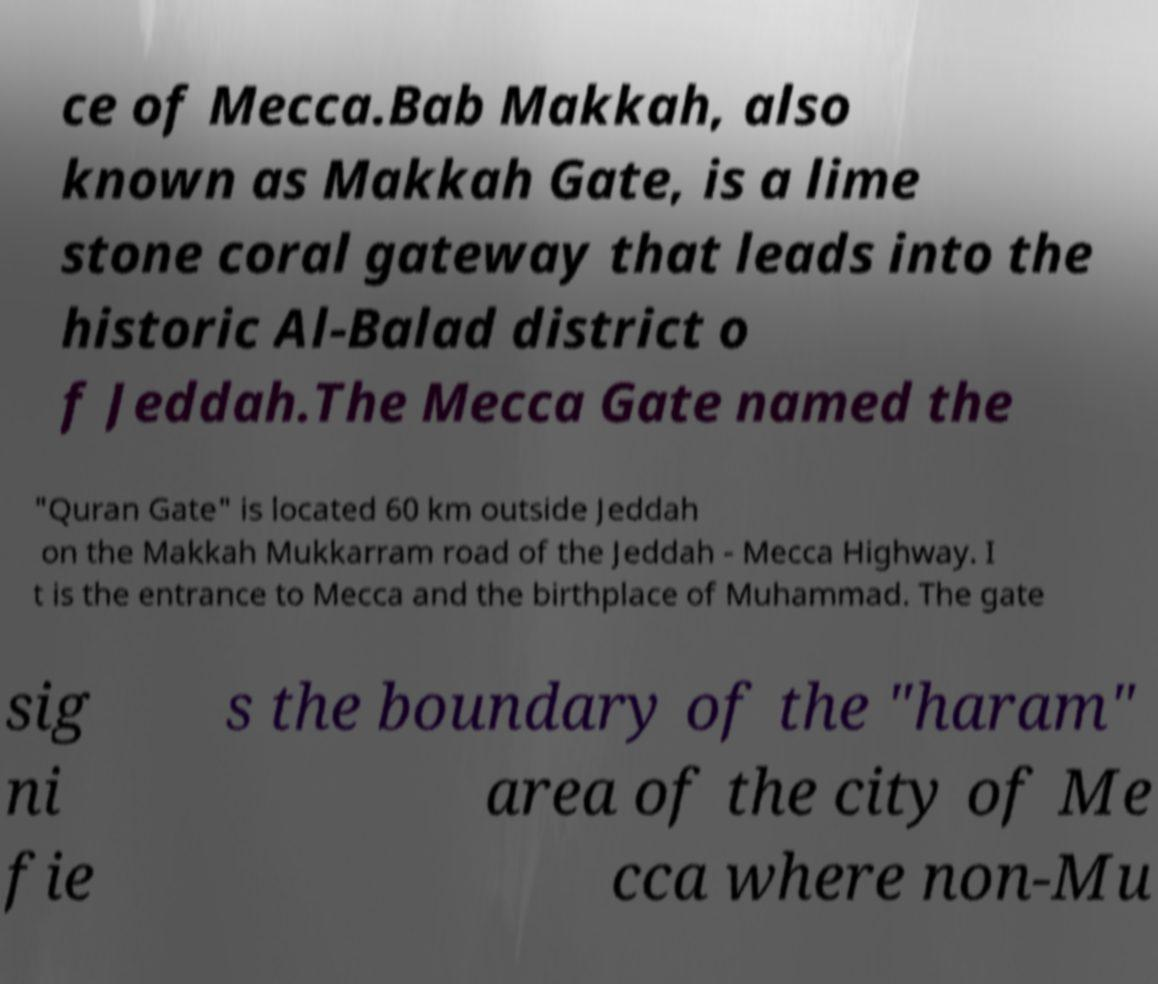There's text embedded in this image that I need extracted. Can you transcribe it verbatim? ce of Mecca.Bab Makkah, also known as Makkah Gate, is a lime stone coral gateway that leads into the historic Al-Balad district o f Jeddah.The Mecca Gate named the "Quran Gate" is located 60 km outside Jeddah on the Makkah Mukkarram road of the Jeddah - Mecca Highway. I t is the entrance to Mecca and the birthplace of Muhammad. The gate sig ni fie s the boundary of the "haram" area of the city of Me cca where non-Mu 